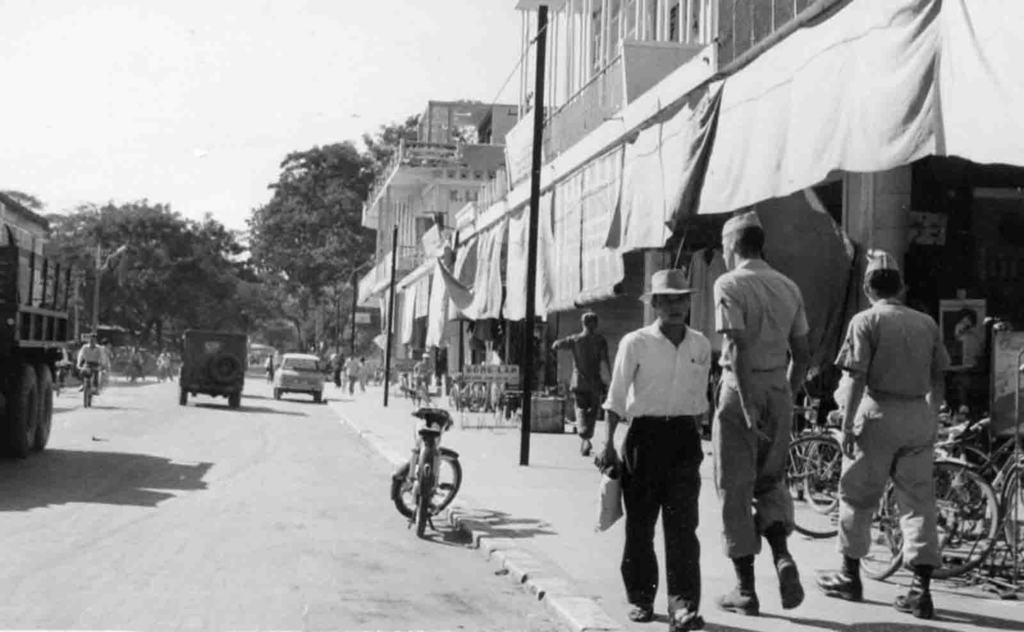Describe this image in one or two sentences. This is a black and white image, in this image there are a few vehicles passing on the road, beside the road on the pavement there are a few people walking and there are cycles parked, on the either side of the road there are lamp posts, trees and there are shops with curtains in front of the buildings. 